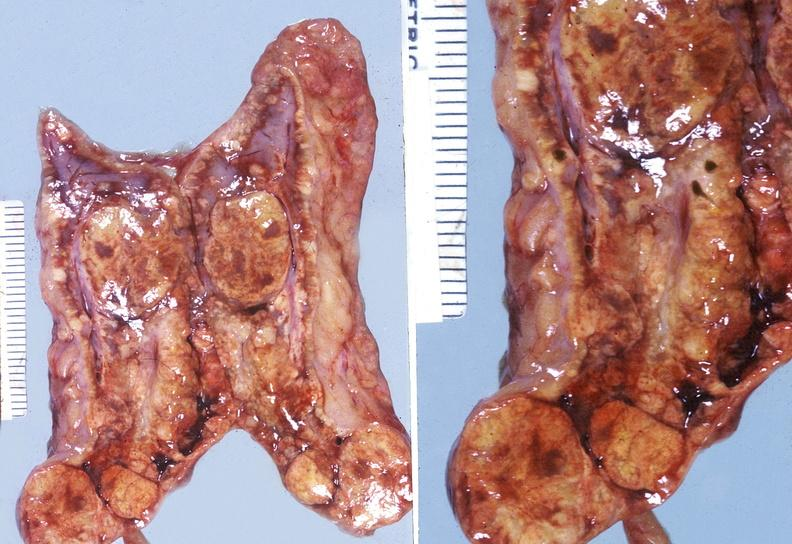s surface present?
Answer the question using a single word or phrase. No 